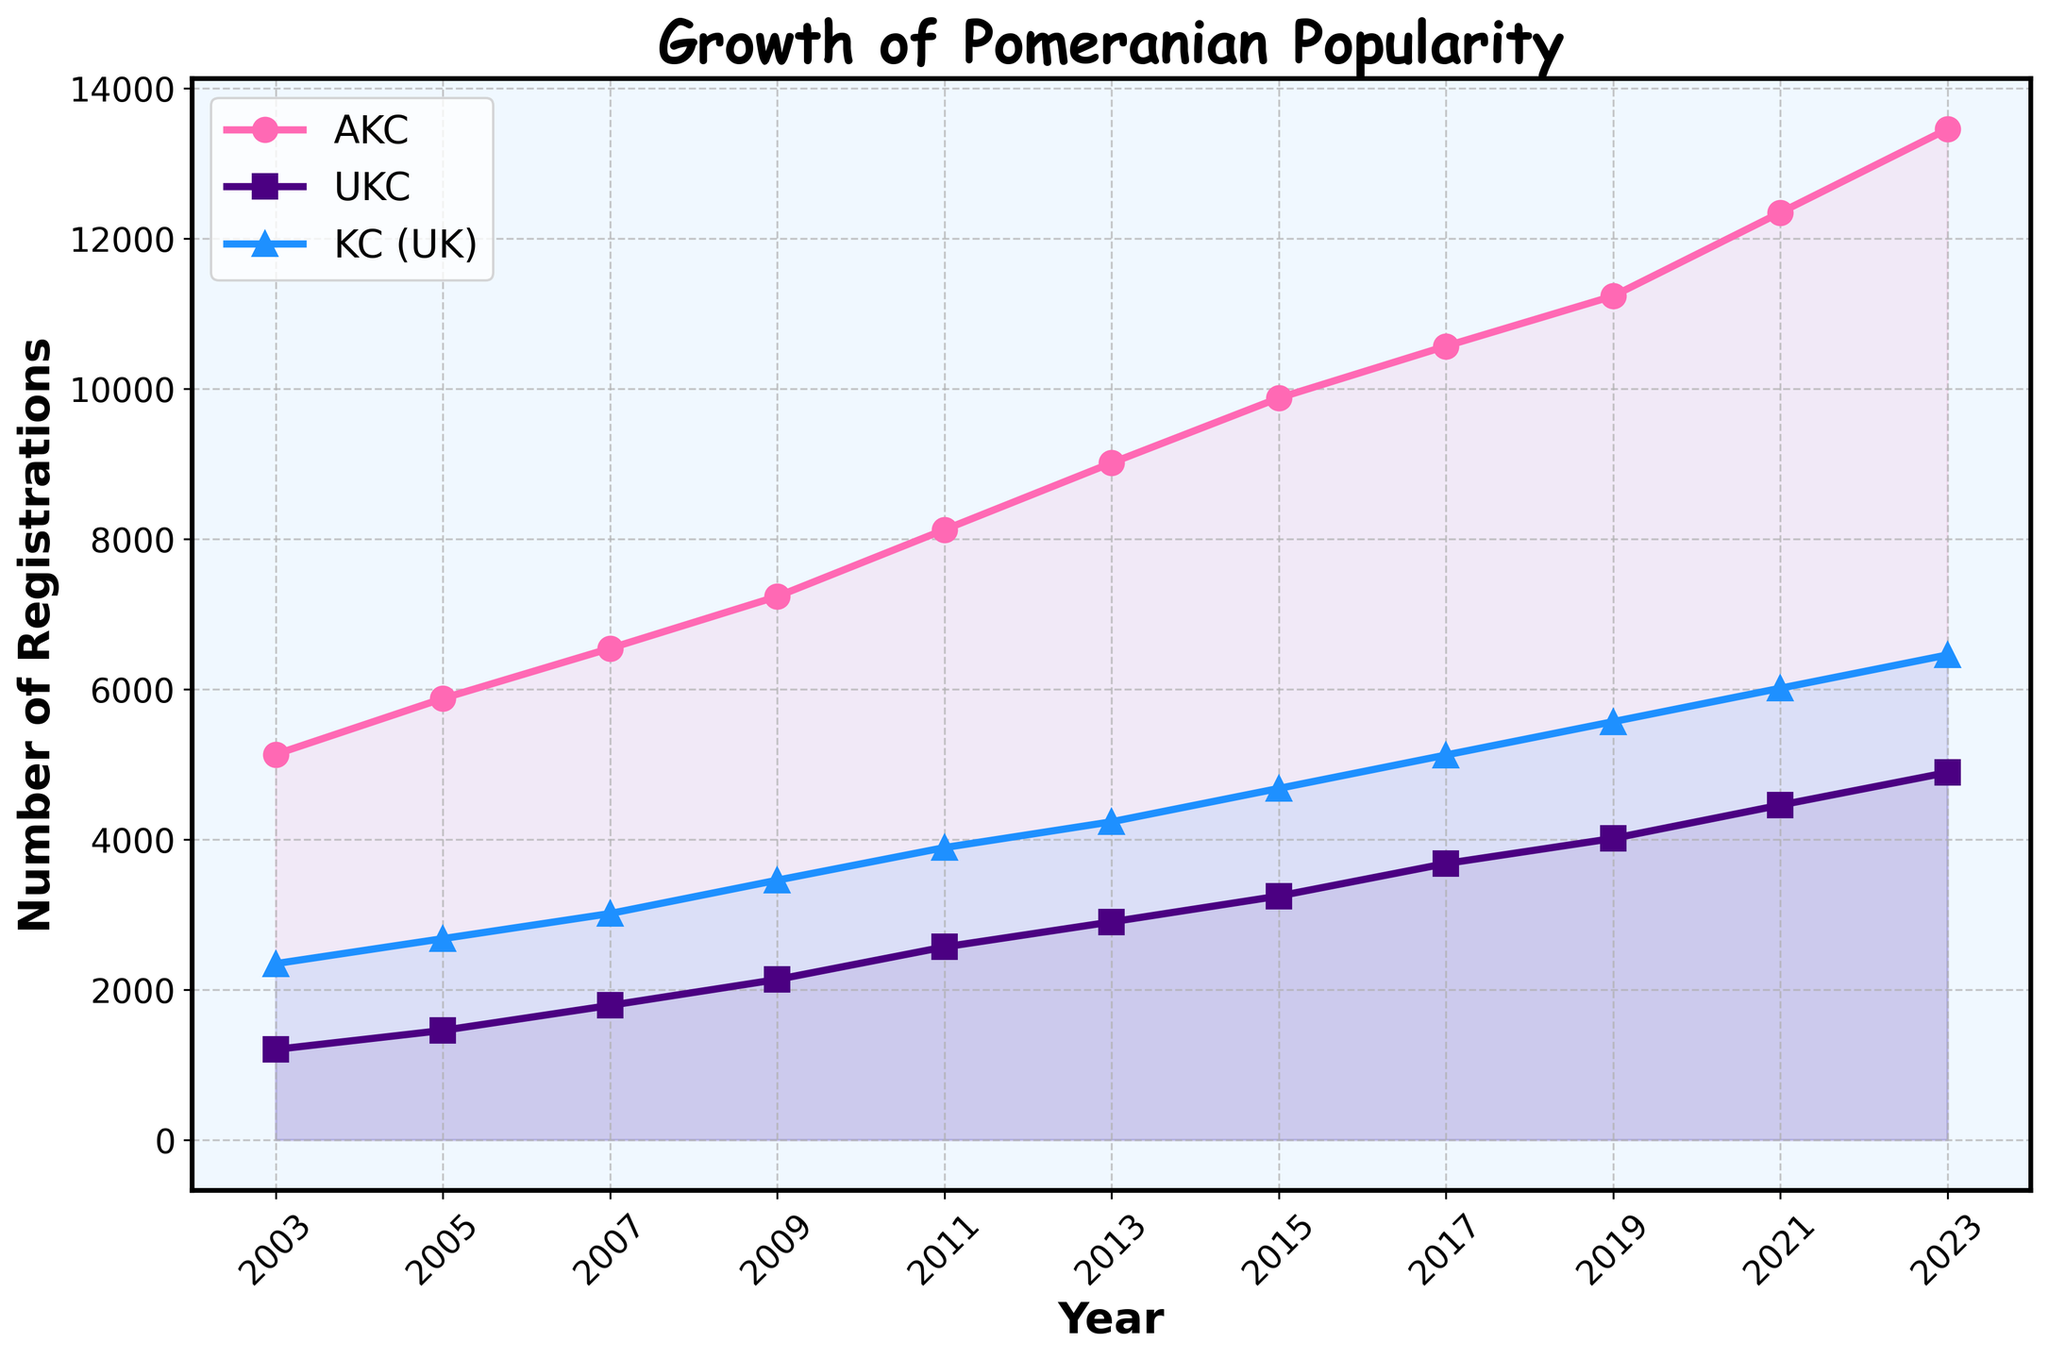What trend does the AKC Registrations data show over the 20 years? To answer this, we look at the pink line (AKC) across the years from 2003 to 2023. It consistently rises, indicating a continuous increase in AKC Registrations over the 20 years.
Answer: Continuous increase Between which two consecutive years did the UKC Registrations see the highest increase? To find this, observe the purple line (UKC) and measure the gaps between the years. The largest gap visually is between 2021 (4456) and 2023 (4890), which gives an increase of 434.
Answer: 2021 and 2023 What is the difference in The Kennel Club (UK) Registrations between the years 2017 and 2023? From the blue line (KC UK), in 2017 it is 5123, and in 2023 it is 6456. The difference is 6456 - 5123.
Answer: 1333 Are AKC Registrations always higher than both UKC and The Kennel Club (UK) Registrations? By examining the three lines, the pink line for AKC is always above the purple (UKC) and blue lines (KC UK) across all years, thus AKC registrations are consistently higher.
Answer: Yes What is the average number of KC (UK) Registrations across all the given years? The KC (UK) registrations from 2003 to 2023 are: 2345, 2678, 3012, 3456, 3890, 4234, 4678, 5123, 5567, 6012, 6456. Sum these values and divide by 11. Average = (2345 + 2678 + 3012 + 3456 + 3890 + 4234 + 4678 + 5123 + 5567 + 6012 + 6456) / 11 = 4744
Answer: 4744 By how much did the total registrations for AKC, UKC, and The Kennel Club (UK) combined increase from 2003 to 2023? First, calculate the total registrations for each year combined. In 2003, the total combined is 5132 (AKC) + 1203 (UKC) + 2345 (KC UK) = 8670. In 2023, the total combined is 13456 + 4890 + 6456 = 24802. The increase is 24802 - 8670.
Answer: 16132 Which year has the closest number of registrations between all three clubs? Might need careful observation, but visibly the year 2005 shows close values: AKC (5876), UKC (1456), KC UK (2678) seem within a closer range compared to other years.
Answer: 2005 What color represents The Kennel Club (UK) Registrations on the chart? Look at the line representing The Kennel Club (UK) and observe its color. The blue line corresponds to The Kennel Club (UK) registrations.
Answer: Blue Does the UKC Registrations line ever cross above the AKC Registrations line? Follow the purple line (UKC) and check if it ever goes above the pink line (AKC); it does not. The UKC line remains below the AKC line throughout.
Answer: No What is the overall trend of registrations for all clubs from 2003 to 2023? By observing all the colorful lines, they all show an upward trend, indicating registration numbers in all clubs have increased.
Answer: Increasing trend 